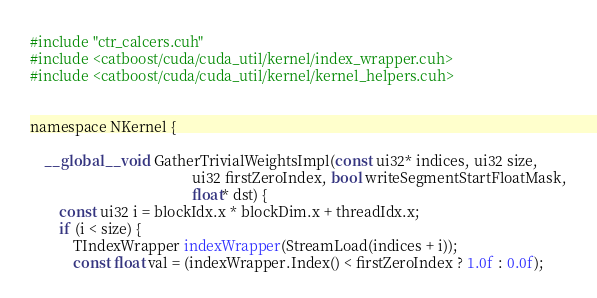<code> <loc_0><loc_0><loc_500><loc_500><_Cuda_>#include "ctr_calcers.cuh"
#include <catboost/cuda/cuda_util/kernel/index_wrapper.cuh>
#include <catboost/cuda/cuda_util/kernel/kernel_helpers.cuh>


namespace NKernel {

    __global__ void GatherTrivialWeightsImpl(const ui32* indices, ui32 size,
                                             ui32 firstZeroIndex, bool writeSegmentStartFloatMask,
                                             float* dst) {
        const ui32 i = blockIdx.x * blockDim.x + threadIdx.x;
        if (i < size) {
            TIndexWrapper indexWrapper(StreamLoad(indices + i));
            const float val = (indexWrapper.Index() < firstZeroIndex ? 1.0f : 0.0f);</code> 